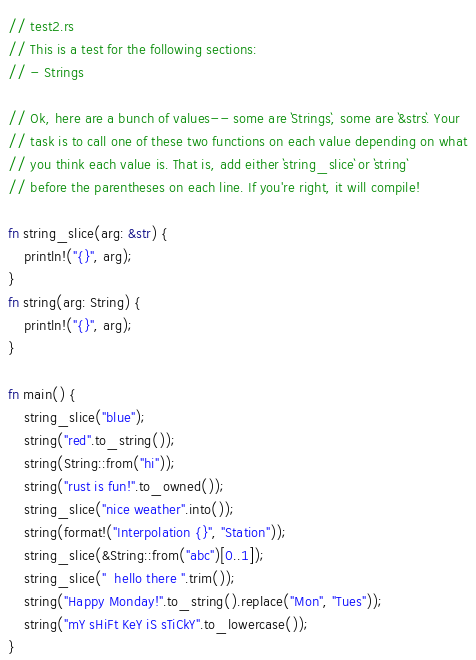<code> <loc_0><loc_0><loc_500><loc_500><_Rust_>// test2.rs
// This is a test for the following sections:
// - Strings

// Ok, here are a bunch of values-- some are `Strings`, some are `&strs`. Your
// task is to call one of these two functions on each value depending on what
// you think each value is. That is, add either `string_slice` or `string`
// before the parentheses on each line. If you're right, it will compile!

fn string_slice(arg: &str) {
    println!("{}", arg);
}
fn string(arg: String) {
    println!("{}", arg);
}

fn main() {
    string_slice("blue");
    string("red".to_string());
    string(String::from("hi"));
    string("rust is fun!".to_owned());
    string_slice("nice weather".into());
    string(format!("Interpolation {}", "Station"));
    string_slice(&String::from("abc")[0..1]);
    string_slice("  hello there ".trim());
    string("Happy Monday!".to_string().replace("Mon", "Tues"));
    string("mY sHiFt KeY iS sTiCkY".to_lowercase());
}
</code> 